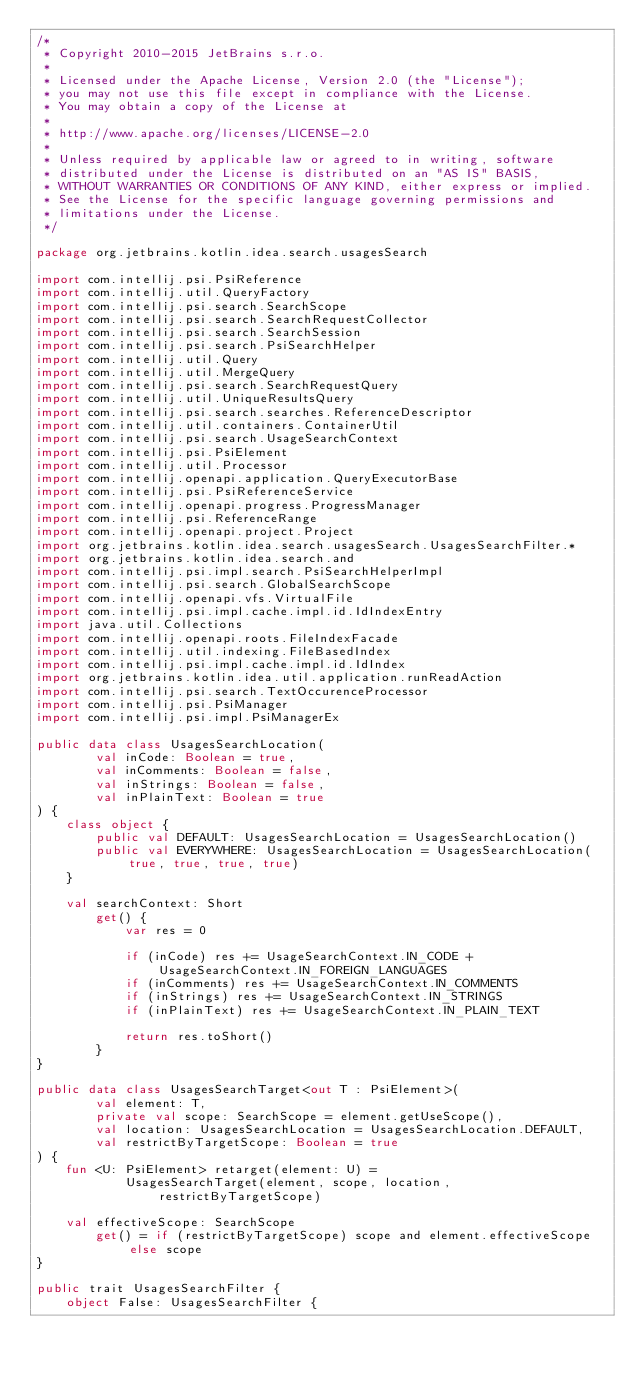Convert code to text. <code><loc_0><loc_0><loc_500><loc_500><_Kotlin_>/*
 * Copyright 2010-2015 JetBrains s.r.o.
 *
 * Licensed under the Apache License, Version 2.0 (the "License");
 * you may not use this file except in compliance with the License.
 * You may obtain a copy of the License at
 *
 * http://www.apache.org/licenses/LICENSE-2.0
 *
 * Unless required by applicable law or agreed to in writing, software
 * distributed under the License is distributed on an "AS IS" BASIS,
 * WITHOUT WARRANTIES OR CONDITIONS OF ANY KIND, either express or implied.
 * See the License for the specific language governing permissions and
 * limitations under the License.
 */

package org.jetbrains.kotlin.idea.search.usagesSearch

import com.intellij.psi.PsiReference
import com.intellij.util.QueryFactory
import com.intellij.psi.search.SearchScope
import com.intellij.psi.search.SearchRequestCollector
import com.intellij.psi.search.SearchSession
import com.intellij.psi.search.PsiSearchHelper
import com.intellij.util.Query
import com.intellij.util.MergeQuery
import com.intellij.psi.search.SearchRequestQuery
import com.intellij.util.UniqueResultsQuery
import com.intellij.psi.search.searches.ReferenceDescriptor
import com.intellij.util.containers.ContainerUtil
import com.intellij.psi.search.UsageSearchContext
import com.intellij.psi.PsiElement
import com.intellij.util.Processor
import com.intellij.openapi.application.QueryExecutorBase
import com.intellij.psi.PsiReferenceService
import com.intellij.openapi.progress.ProgressManager
import com.intellij.psi.ReferenceRange
import com.intellij.openapi.project.Project
import org.jetbrains.kotlin.idea.search.usagesSearch.UsagesSearchFilter.*
import org.jetbrains.kotlin.idea.search.and
import com.intellij.psi.impl.search.PsiSearchHelperImpl
import com.intellij.psi.search.GlobalSearchScope
import com.intellij.openapi.vfs.VirtualFile
import com.intellij.psi.impl.cache.impl.id.IdIndexEntry
import java.util.Collections
import com.intellij.openapi.roots.FileIndexFacade
import com.intellij.util.indexing.FileBasedIndex
import com.intellij.psi.impl.cache.impl.id.IdIndex
import org.jetbrains.kotlin.idea.util.application.runReadAction
import com.intellij.psi.search.TextOccurenceProcessor
import com.intellij.psi.PsiManager
import com.intellij.psi.impl.PsiManagerEx

public data class UsagesSearchLocation(
        val inCode: Boolean = true,
        val inComments: Boolean = false,
        val inStrings: Boolean = false,
        val inPlainText: Boolean = true
) {
    class object {
        public val DEFAULT: UsagesSearchLocation = UsagesSearchLocation()
        public val EVERYWHERE: UsagesSearchLocation = UsagesSearchLocation(true, true, true, true)
    }

    val searchContext: Short
        get() {
            var res = 0

            if (inCode) res += UsageSearchContext.IN_CODE + UsageSearchContext.IN_FOREIGN_LANGUAGES
            if (inComments) res += UsageSearchContext.IN_COMMENTS
            if (inStrings) res += UsageSearchContext.IN_STRINGS
            if (inPlainText) res += UsageSearchContext.IN_PLAIN_TEXT

            return res.toShort()
        }
}

public data class UsagesSearchTarget<out T : PsiElement>(
        val element: T,
        private val scope: SearchScope = element.getUseScope(),
        val location: UsagesSearchLocation = UsagesSearchLocation.DEFAULT,
        val restrictByTargetScope: Boolean = true
) {
    fun <U: PsiElement> retarget(element: U) =
            UsagesSearchTarget(element, scope, location, restrictByTargetScope)

    val effectiveScope: SearchScope
        get() = if (restrictByTargetScope) scope and element.effectiveScope else scope
}

public trait UsagesSearchFilter {
    object False: UsagesSearchFilter {</code> 